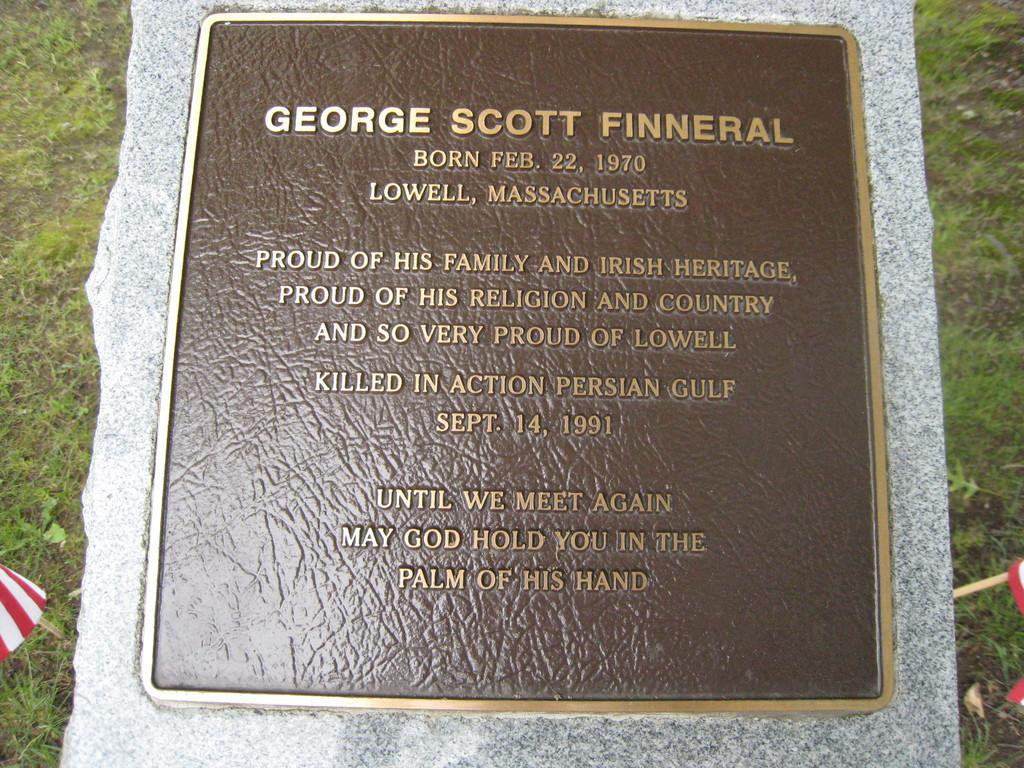What is the main object in the image? There is a headstone in the image. What can be found on the headstone? There is writing on the headstone. What type of shoes is the person wearing in the image? There is no person present in the image, so it is not possible to determine what type of shoes they might be wearing. 